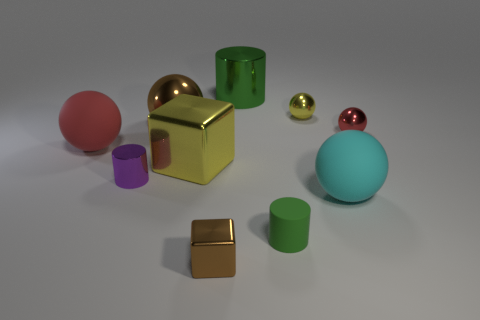What is the shape of the metal thing that is the same color as the small shiny block?
Ensure brevity in your answer.  Sphere. What is the material of the red sphere left of the tiny red shiny sphere?
Provide a succinct answer. Rubber. What number of things are big metal cylinders or balls that are behind the red matte thing?
Your answer should be compact. 4. What is the shape of the green metallic thing that is the same size as the cyan matte sphere?
Your answer should be very brief. Cylinder. How many other things have the same color as the small rubber object?
Provide a short and direct response. 1. Is the big thing in front of the large block made of the same material as the large red thing?
Offer a very short reply. Yes. What shape is the small red metallic object?
Make the answer very short. Sphere. How many green objects are metal objects or small metallic balls?
Provide a succinct answer. 1. What number of other objects are the same material as the small brown cube?
Provide a short and direct response. 6. There is a big rubber object that is on the right side of the big brown metallic object; is it the same shape as the small green rubber thing?
Your answer should be compact. No. 